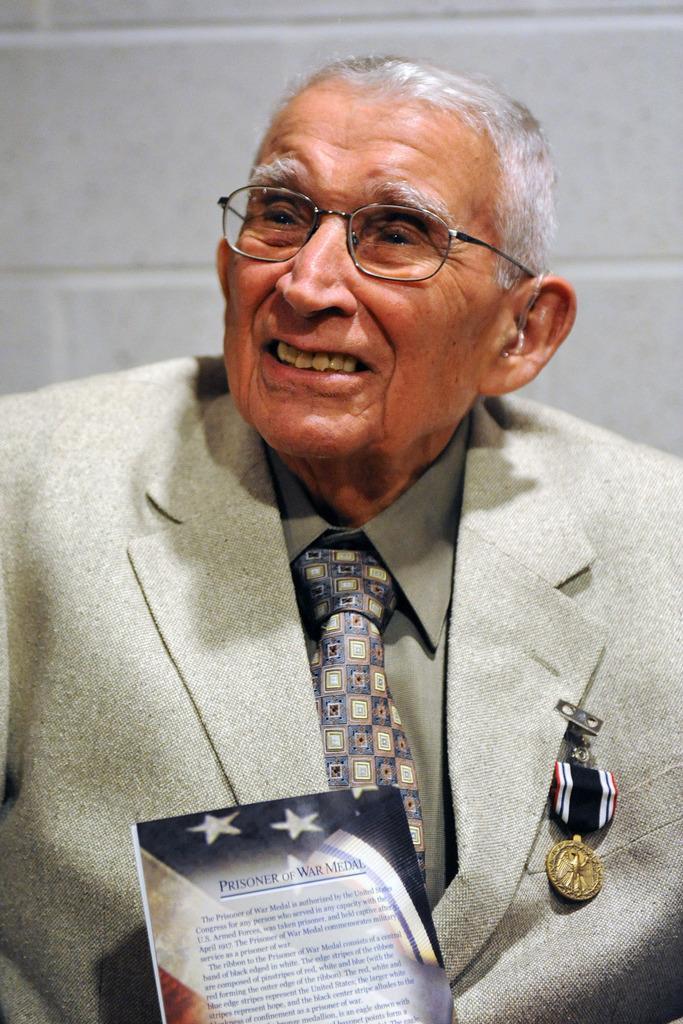Describe this image in one or two sentences. In this image I can see an old man and and I can see he is wearing shirt, tie and blazer. I can also see a medal over here and I can see he is wearing specs. I can also see something is written over here. 